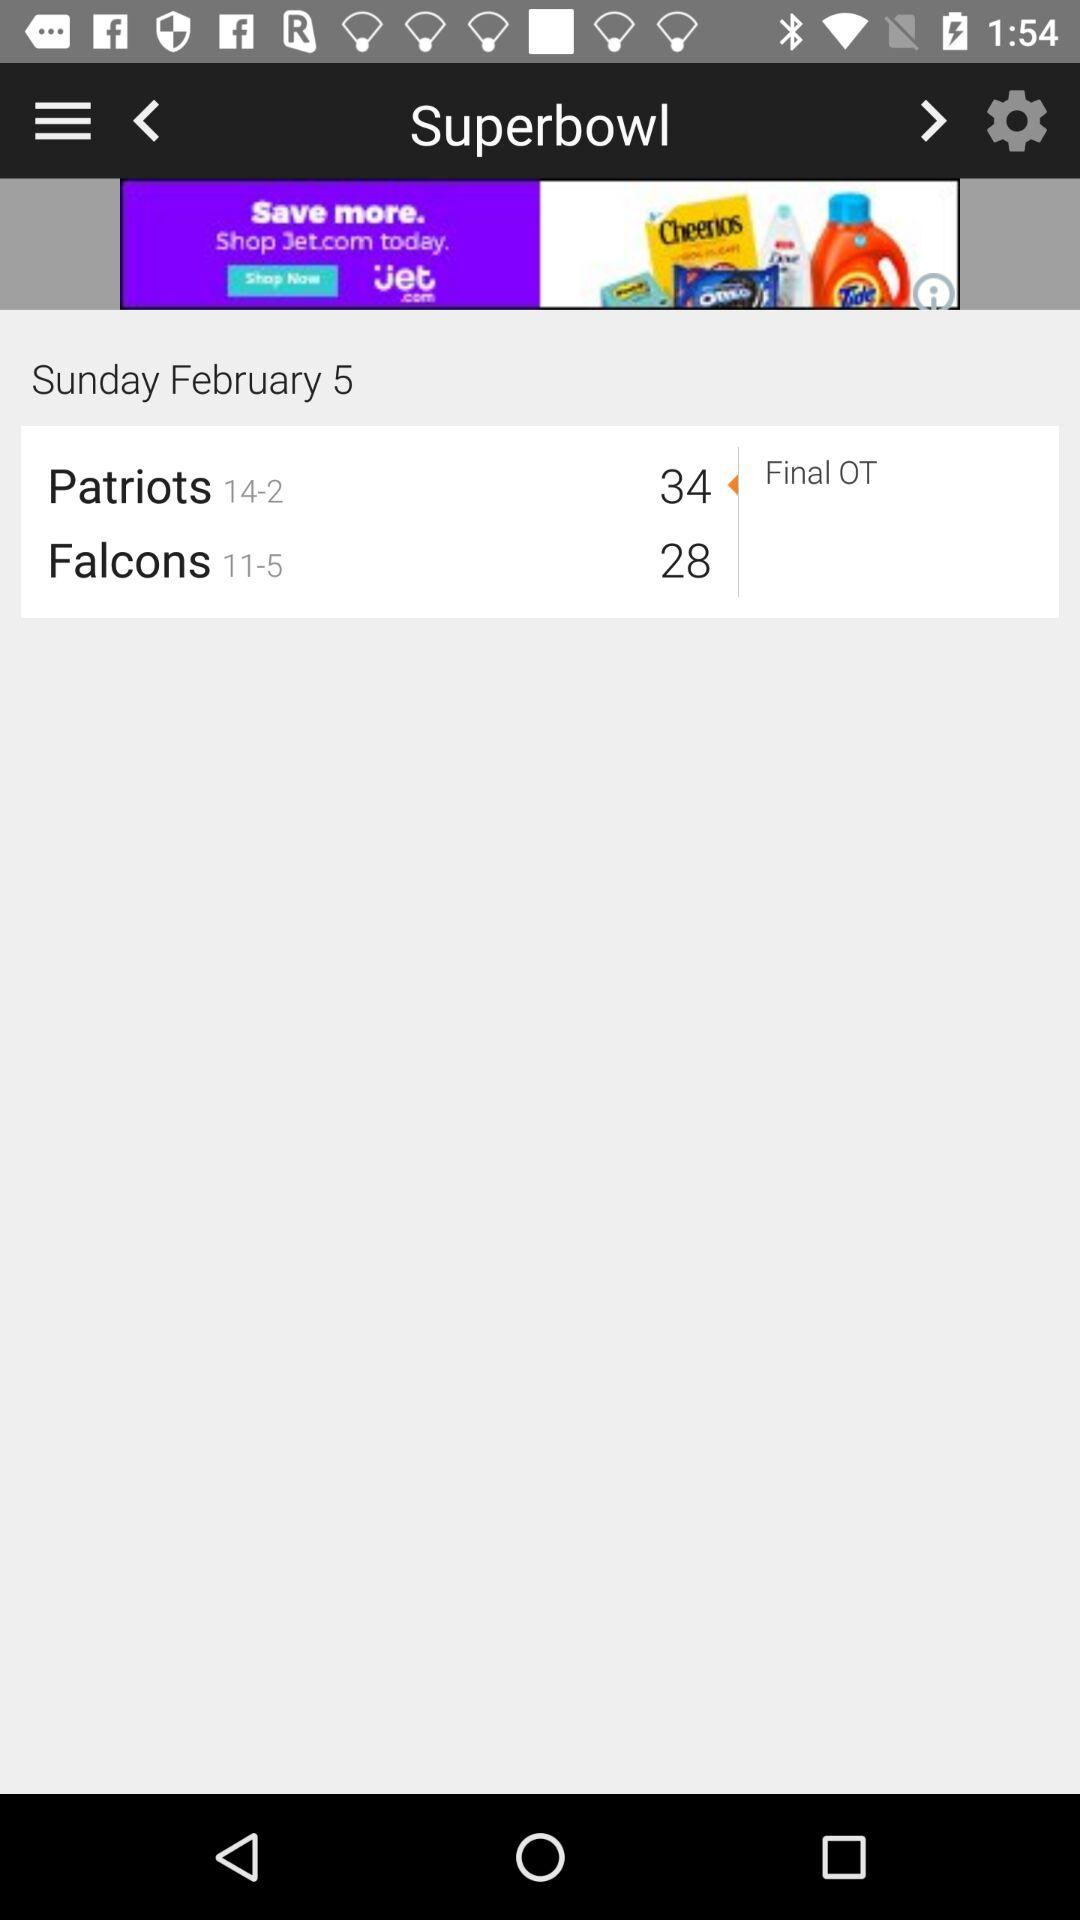How many more points did the Patriots score than the Falcons?
Answer the question using a single word or phrase. 6 